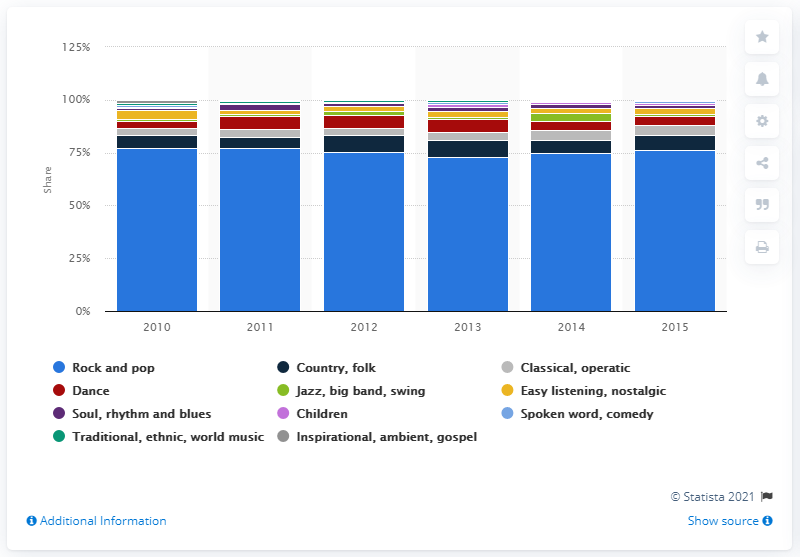Outline some significant characteristics in this image. In Australia, classical and opera music accounted for 4.7% of total music sales in 2021. 